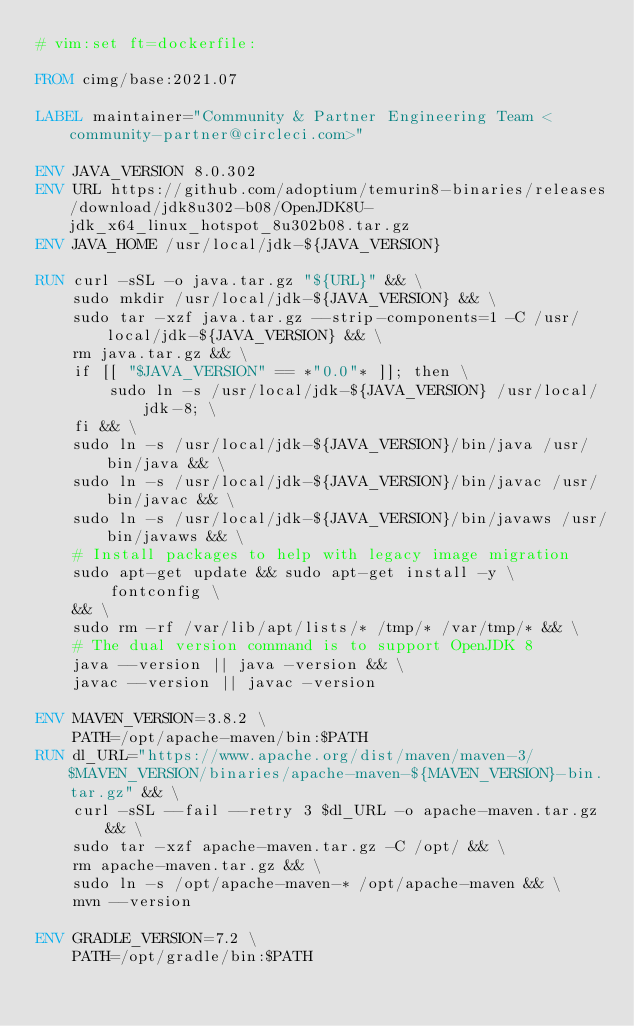<code> <loc_0><loc_0><loc_500><loc_500><_Dockerfile_># vim:set ft=dockerfile:

FROM cimg/base:2021.07

LABEL maintainer="Community & Partner Engineering Team <community-partner@circleci.com>"

ENV JAVA_VERSION 8.0.302
ENV URL https://github.com/adoptium/temurin8-binaries/releases/download/jdk8u302-b08/OpenJDK8U-jdk_x64_linux_hotspot_8u302b08.tar.gz
ENV JAVA_HOME /usr/local/jdk-${JAVA_VERSION}

RUN curl -sSL -o java.tar.gz "${URL}" && \
	sudo mkdir /usr/local/jdk-${JAVA_VERSION} && \
	sudo tar -xzf java.tar.gz --strip-components=1 -C /usr/local/jdk-${JAVA_VERSION} && \
	rm java.tar.gz && \
	if [[ "$JAVA_VERSION" == *"0.0"* ]]; then \
		sudo ln -s /usr/local/jdk-${JAVA_VERSION} /usr/local/jdk-8; \
	fi && \
	sudo ln -s /usr/local/jdk-${JAVA_VERSION}/bin/java /usr/bin/java && \
	sudo ln -s /usr/local/jdk-${JAVA_VERSION}/bin/javac /usr/bin/javac && \
	sudo ln -s /usr/local/jdk-${JAVA_VERSION}/bin/javaws /usr/bin/javaws && \
	# Install packages to help with legacy image migration
	sudo apt-get update && sudo apt-get install -y \
		fontconfig \
	&& \
	sudo rm -rf /var/lib/apt/lists/* /tmp/* /var/tmp/* && \
	# The dual version command is to support OpenJDK 8
	java --version || java -version && \
	javac --version || javac -version

ENV MAVEN_VERSION=3.8.2 \
	PATH=/opt/apache-maven/bin:$PATH
RUN dl_URL="https://www.apache.org/dist/maven/maven-3/$MAVEN_VERSION/binaries/apache-maven-${MAVEN_VERSION}-bin.tar.gz" && \
	curl -sSL --fail --retry 3 $dl_URL -o apache-maven.tar.gz && \
	sudo tar -xzf apache-maven.tar.gz -C /opt/ && \
	rm apache-maven.tar.gz && \
	sudo ln -s /opt/apache-maven-* /opt/apache-maven && \
	mvn --version

ENV GRADLE_VERSION=7.2 \
	PATH=/opt/gradle/bin:$PATH</code> 